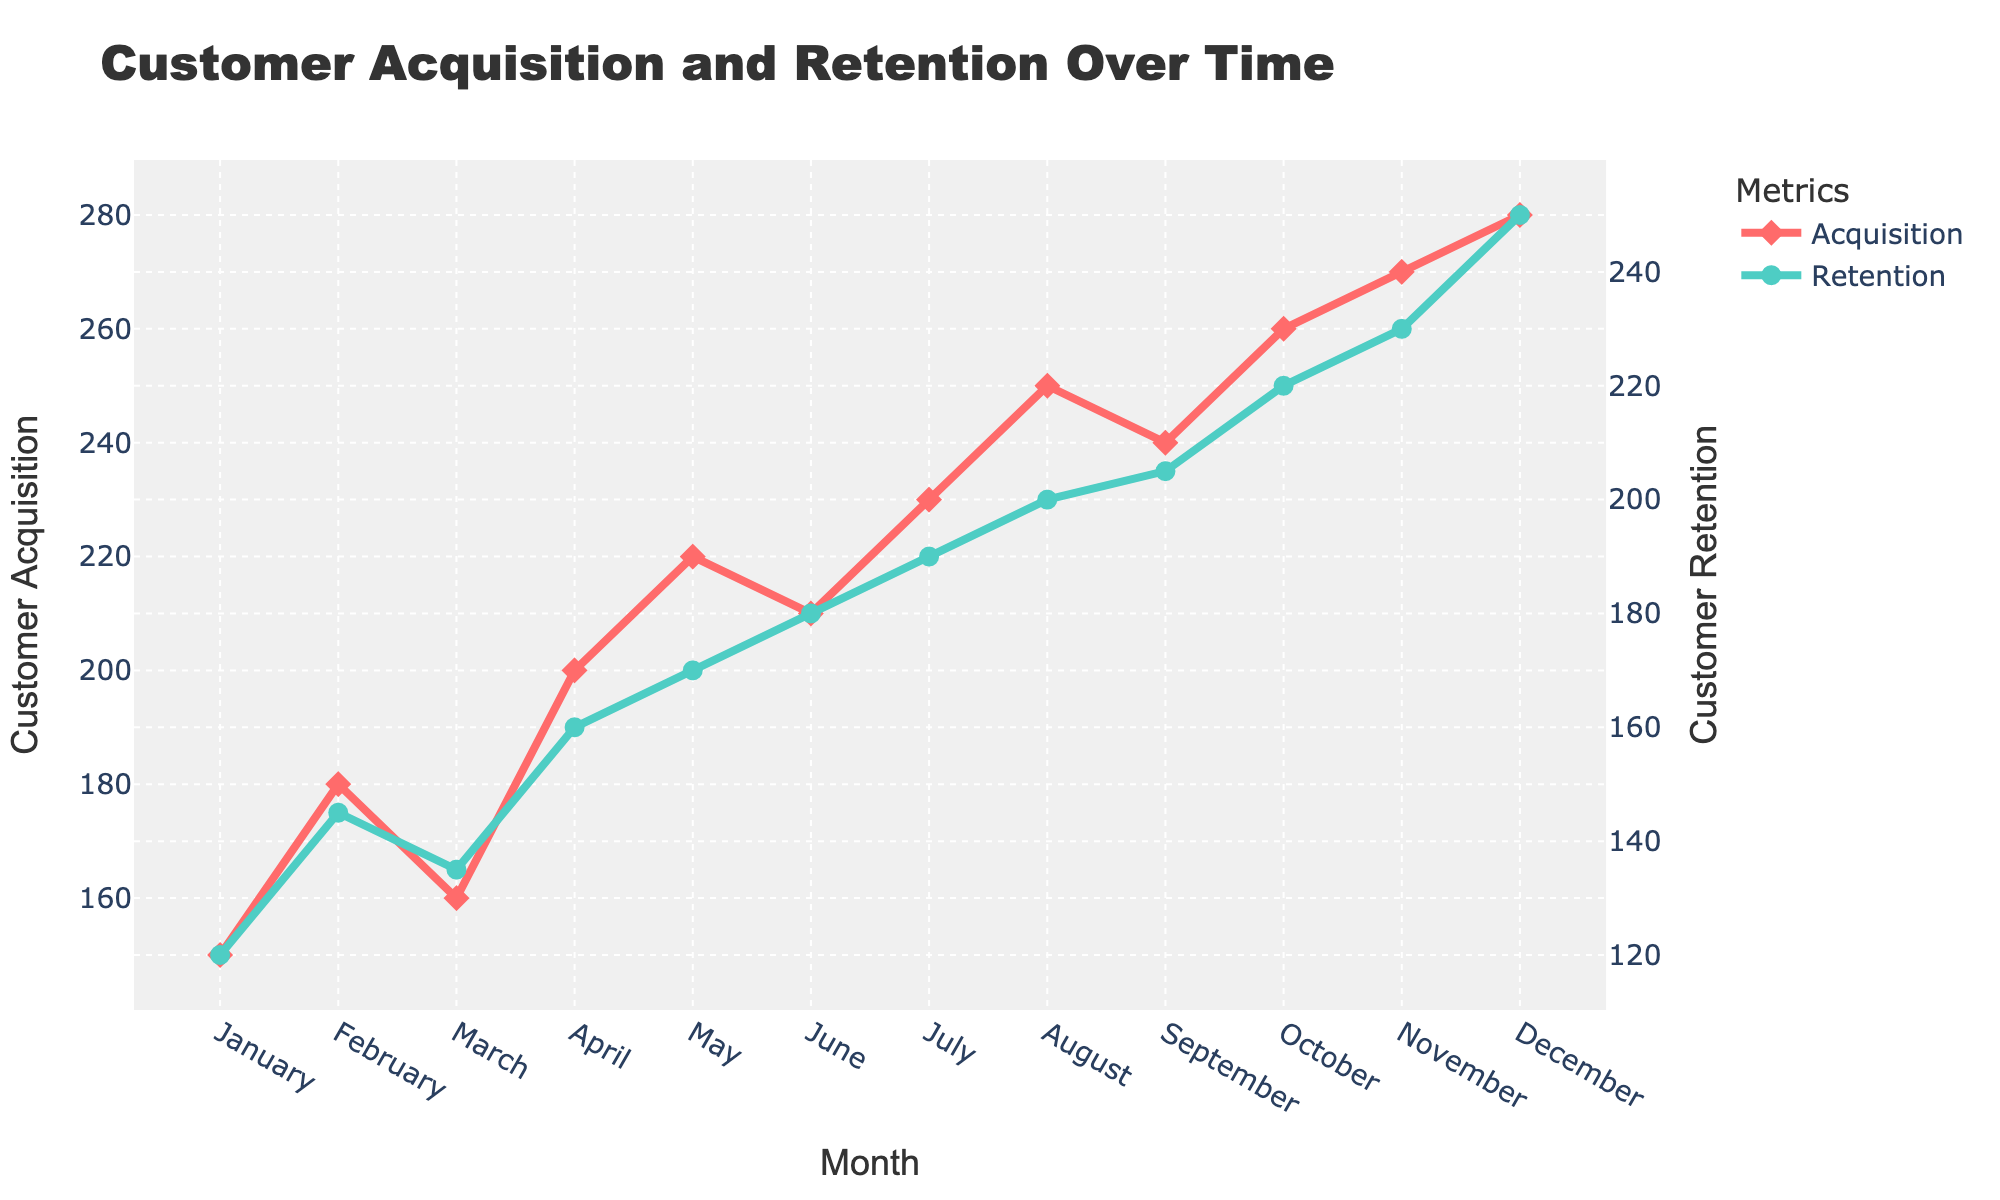What is the title of the figure? The title of the figure is displayed at the top of the plot. It is "Customer Acquisition and Retention Over Time".
Answer: Customer Acquisition and Retention Over Time How many months are displayed in the plot? The x-axis labels range from January to December, indicating that there are 12 months displayed in the plot.
Answer: 12 What colors represent Customer Acquisition and Customer Retention? The lines for Customer Acquisition and Customer Retention have different colors: Customer Acquisition is represented by a red line, and Customer Retention is represented by a teal line.
Answer: Red and teal In which month did Customer Retention first exceed 200? By examining the teal line on the plot, we see that Customer Retention first exceeds 200 in August.
Answer: August What is the difference between Customer Acquisition and Customer Retention in December? From the plot, Customer Acquisition in December is 280 and Customer Retention is 250. The difference is 280 - 250.
Answer: 30 Which month showed the highest Customer Acquisition rate? The plot shows the red line peaking in December, indicating the highest Customer Acquisition rate of 280 in that month.
Answer: December By how much did Customer Retention increase from January to December? Customer Retention in January is 120, and in December it is 250. The increase is 250 - 120.
Answer: 130 Which month had the lowest Customer Retention rate following the initial month? From the plot, the lowest Customer Retention value after January appears in February with a value of 145.
Answer: February What is the trend of Customer Acquisition over the months? Examining the red line over time, Customer Acquisition shows a general increasing trend from January to December.
Answer: Increasing Compare the increase in Customer Acquisition from January to February with the increase from November to December. Which is greater? From January to February, Customer Acquisition rose from 150 to 180 (increase of 30). From November to December, it increased from 270 to 280 (increase of 10). Thus, the increase from January to February is greater.
Answer: January to February 